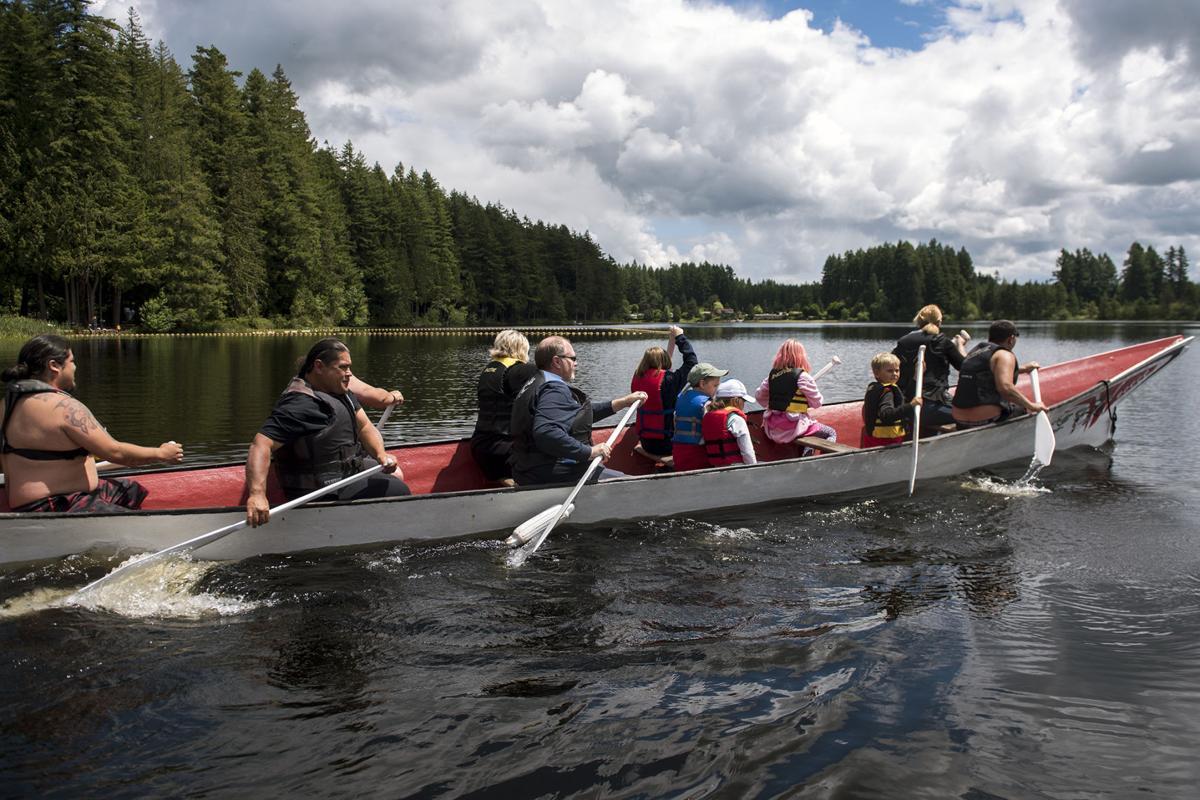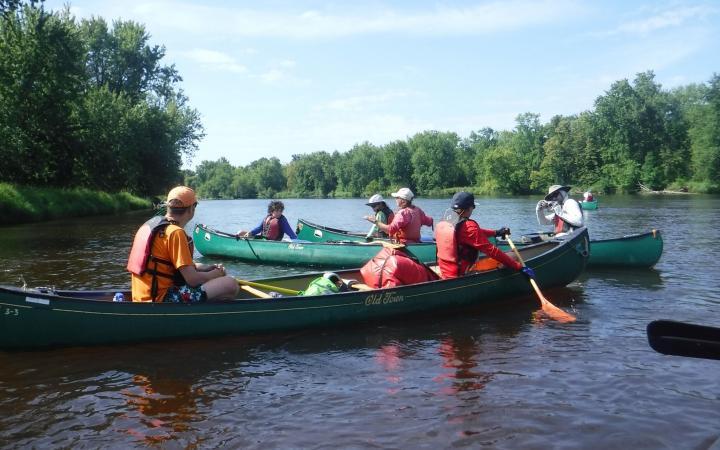The first image is the image on the left, the second image is the image on the right. Given the left and right images, does the statement "In the red boat in the left image, there are three people." hold true? Answer yes or no. No. The first image is the image on the left, the second image is the image on the right. For the images displayed, is the sentence "The left image shows three people in a lefward-facing horizontal red-orange canoe." factually correct? Answer yes or no. No. 